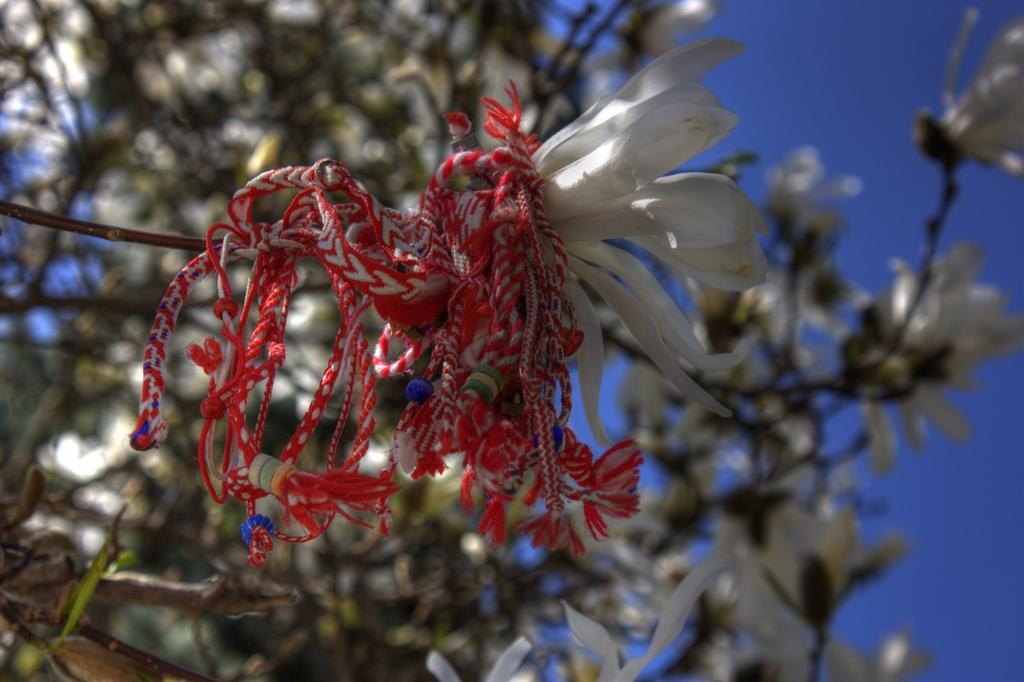What type of flower is in the image? There is a white flower in the image. Is there anything on the white flower? Yes, there is an object on the white flower. What can be seen in the background of the image? There are other flowers in the background of the image. What type of nerve can be seen in the image? There is no nerve present in the image; it features a white flower with an object on it and other flowers in the background. 